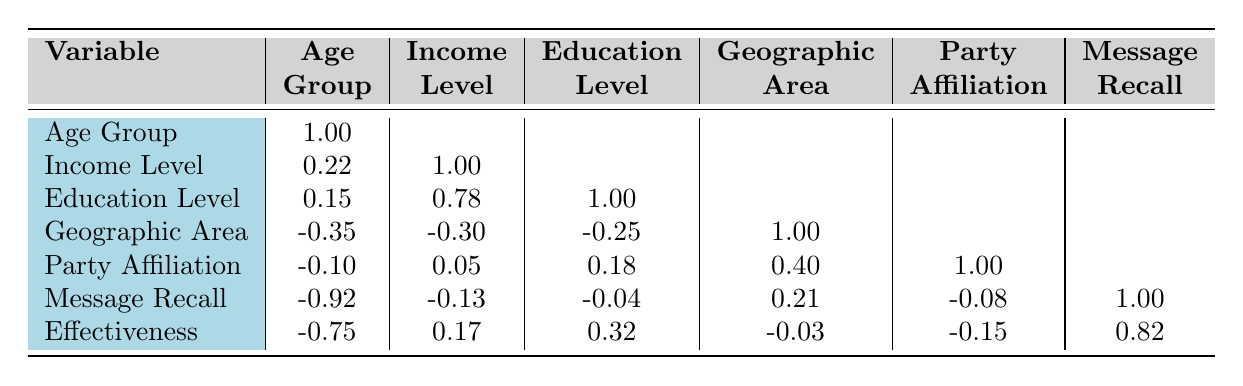What is the campaign message recall for the 25-34 age group? The table indicates that the campaign message recall for the 25-34 age group is 80.
Answer: 80 Is there a positive correlation between income level and education level? The correlation coefficient between income level and education level is 0.78, which indicates a strong positive correlation.
Answer: Yes What is the average campaign effectiveness score for the rural geographic area? The rural group includes two data points: 45-54 age group (60) and 55+ age group (55). The average effectiveness score is (60 + 55) / 2 = 57.5.
Answer: 57.5 Does party affiliation have a strong correlation with campaign effectiveness score? The correlation coefficient between party affiliation and campaign effectiveness score is -0.15, which indicates a weak negative correlation.
Answer: No What is the difference in campaign message recall between the 18-24 age group and the 55+ age group? The campaign message recall for the 18-24 age group is 75, and for the 55+ age group, it is 65. The difference is 75 - 65 = 10.
Answer: 10 What is the campaign effectiveness score for the demographic group with the highest education level? The demographic group with the highest education level is the 35-44 age group with a Master's Degree, and the campaign effectiveness score is 75.
Answer: 75 Is the average campaign message recall greater for urban areas compared to rural areas? The urban areas include the 18-24 (75) and 35-44 (70) age groups, averaging (75 + 70) / 2 = 72.5. The rural areas include the 45-54 (68) and 55+ (65) age groups, averaging (68 + 65) / 2 = 66.5. Since 72.5 > 66.5, the answer is yes.
Answer: Yes What is the correlation between campaign message recall and effectiveness score? The correlation coefficient between campaign message recall and effectiveness score is 0.82, indicating a strong positive correlation.
Answer: Strong positive 